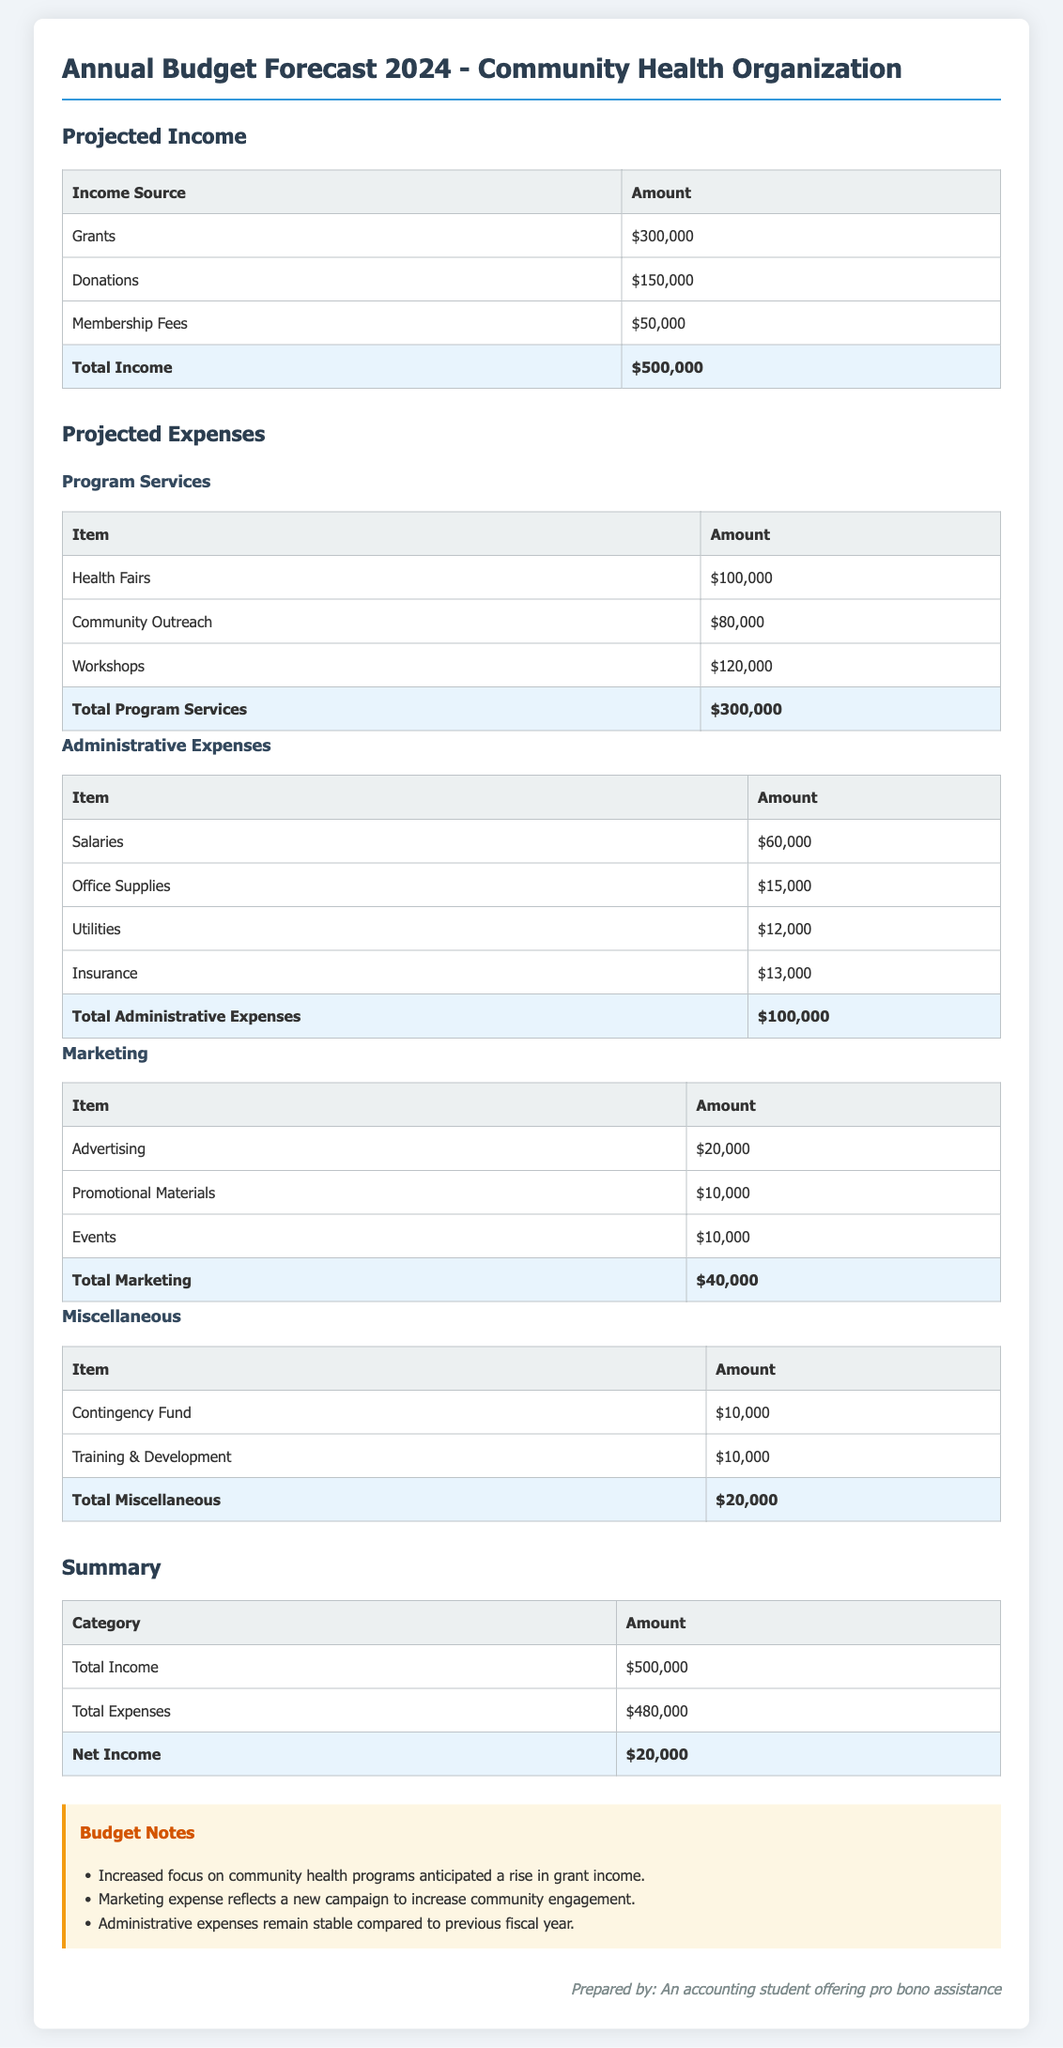What is the total income? The total income is the sum of all income sources listed in the document, which is $300,000 + $150,000 + $50,000 = $500,000.
Answer: $500,000 What is the total for program services? The total for program services is calculated by adding the costs of Health Fairs, Community Outreach, and Workshops, which equals $100,000 + $80,000 + $120,000 = $300,000.
Answer: $300,000 How much is allocated for salaries? The allocation for salaries is stated in the administrative expenses section of the document.
Answer: $60,000 What is the total expense for marketing? The total expense for marketing is the sum of Advertising, Promotional Materials, and Events, which equals $20,000 + $10,000 + $10,000 = $40,000.
Answer: $40,000 What is the net income for 2024? The net income is derived from subtracting total expenses from total income, which is $500,000 - $480,000 = $20,000.
Answer: $20,000 What amount is set aside for the contingency fund? The amount set aside for the contingency fund is specified in the miscellaneous expenses section of the document.
Answer: $10,000 What are the total administrative expenses? The total administrative expenses consist of the sum of salaries, office supplies, utilities, and insurance, which equals $60,000 + $15,000 + $12,000 + $13,000 = $100,000.
Answer: $100,000 What is the amount for donations? The amount specified for donations is listed under projected income in the document.
Answer: $150,000 What percentage of total income is attributed to grants? The grants amount to $300,000, which is 60% of the total income of $500,000.
Answer: 60% 